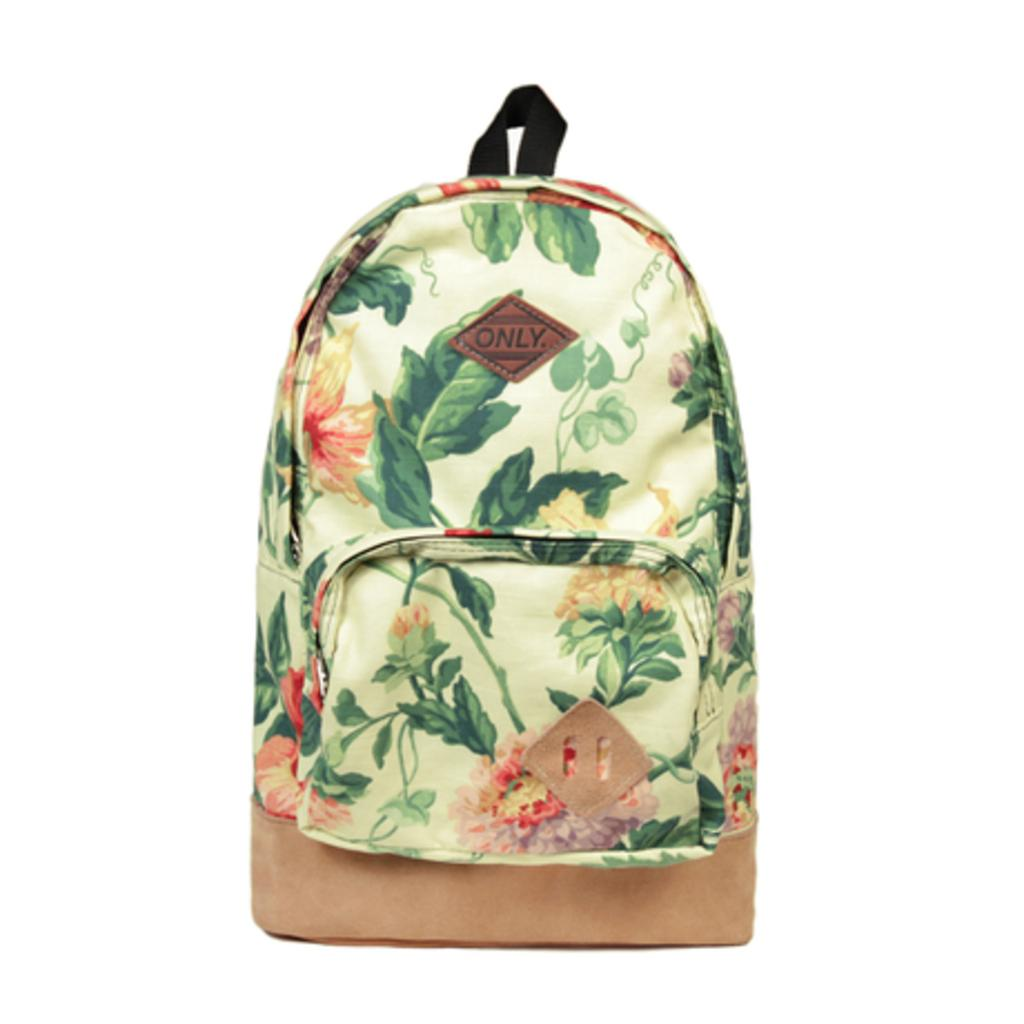<image>
Give a short and clear explanation of the subsequent image. An ONLY backpack with a floral design on it. 